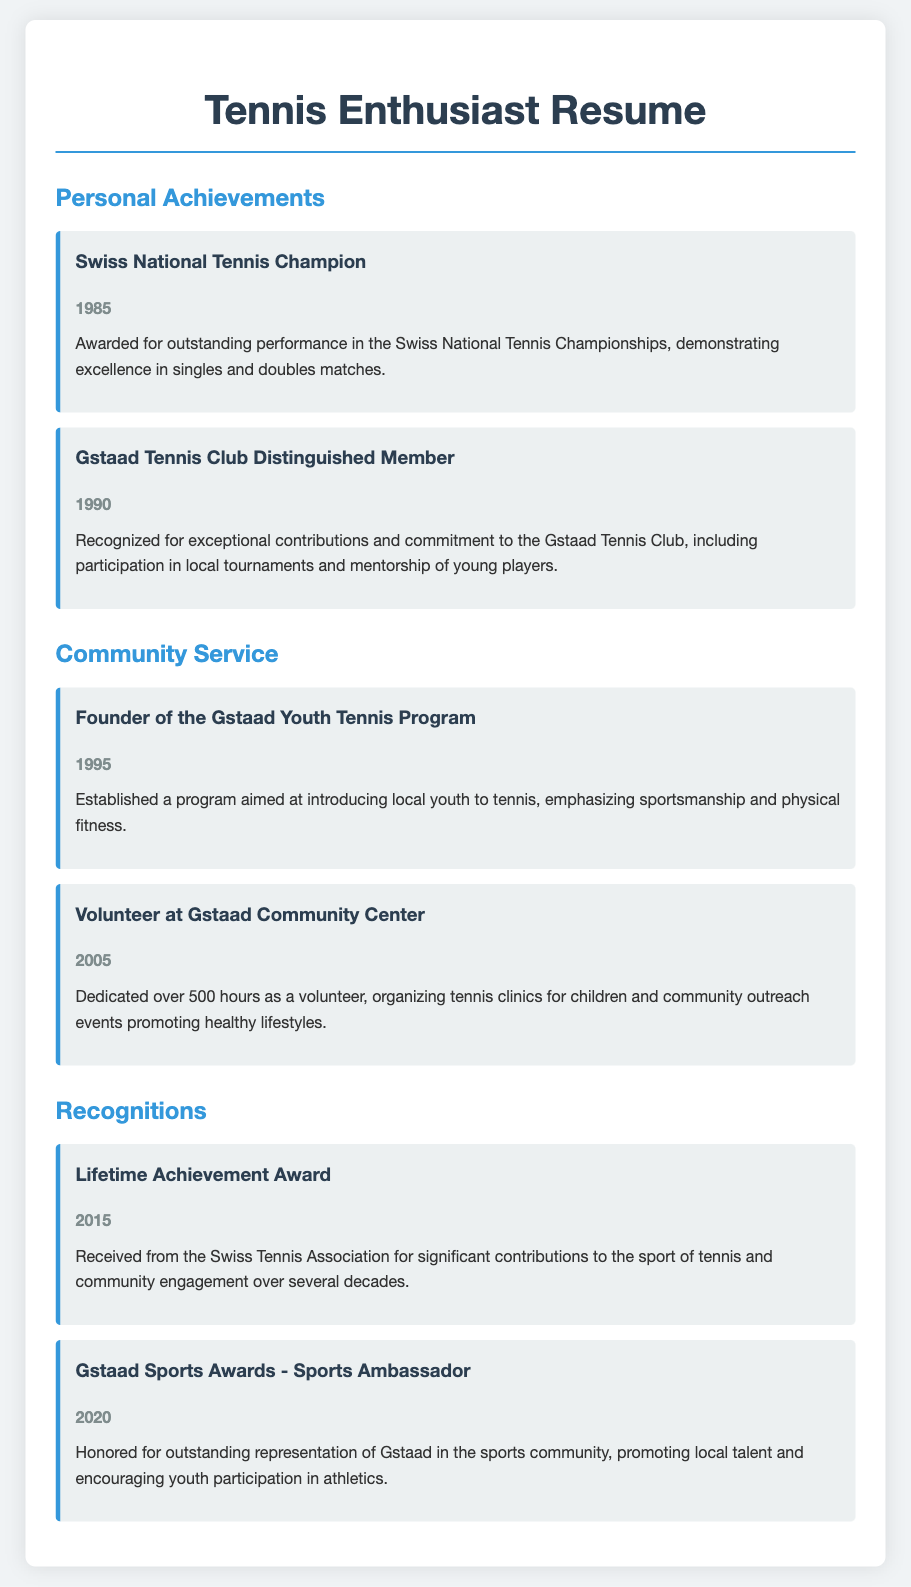What award was received in 1985? The award received in 1985 was for the Swiss National Tennis Championships.
Answer: Swiss National Tennis Champion What significant role was taken on in 1995? In 1995, the significant role taken on was the establishment of a youth program for tennis.
Answer: Founder of the Gstaad Youth Tennis Program How many hours were dedicated to volunteering in 2005? The document states that over 500 hours were dedicated to volunteering in 2005.
Answer: 500 hours Which award was received from the Swiss Tennis Association in 2015? The award received from the Swiss Tennis Association in 2015 is listed as a Lifetime Achievement Award.
Answer: Lifetime Achievement Award In what year was the Gstaad Tennis Club Distinguished Member award given? The Gstaad Tennis Club Distinguished Member award was given in the year 1990.
Answer: 1990 What was the focus of the Gstaad Youth Tennis Program established in 1995? The focus of the program was to introduce local youth to tennis with an emphasis on sportsmanship and physical fitness.
Answer: Sportsmanship and physical fitness Which award recognized the individual as a Sports Ambassador in 2020? The award that recognized them as a Sports Ambassador in 2020 is the Gstaad Sports Awards.
Answer: Gstaad Sports Awards - Sports Ambassador What type of contributions led to the Lifetime Achievement Award? The contributions that led to this award were significant contributions to tennis and community engagement.
Answer: Contributions to tennis and community engagement 